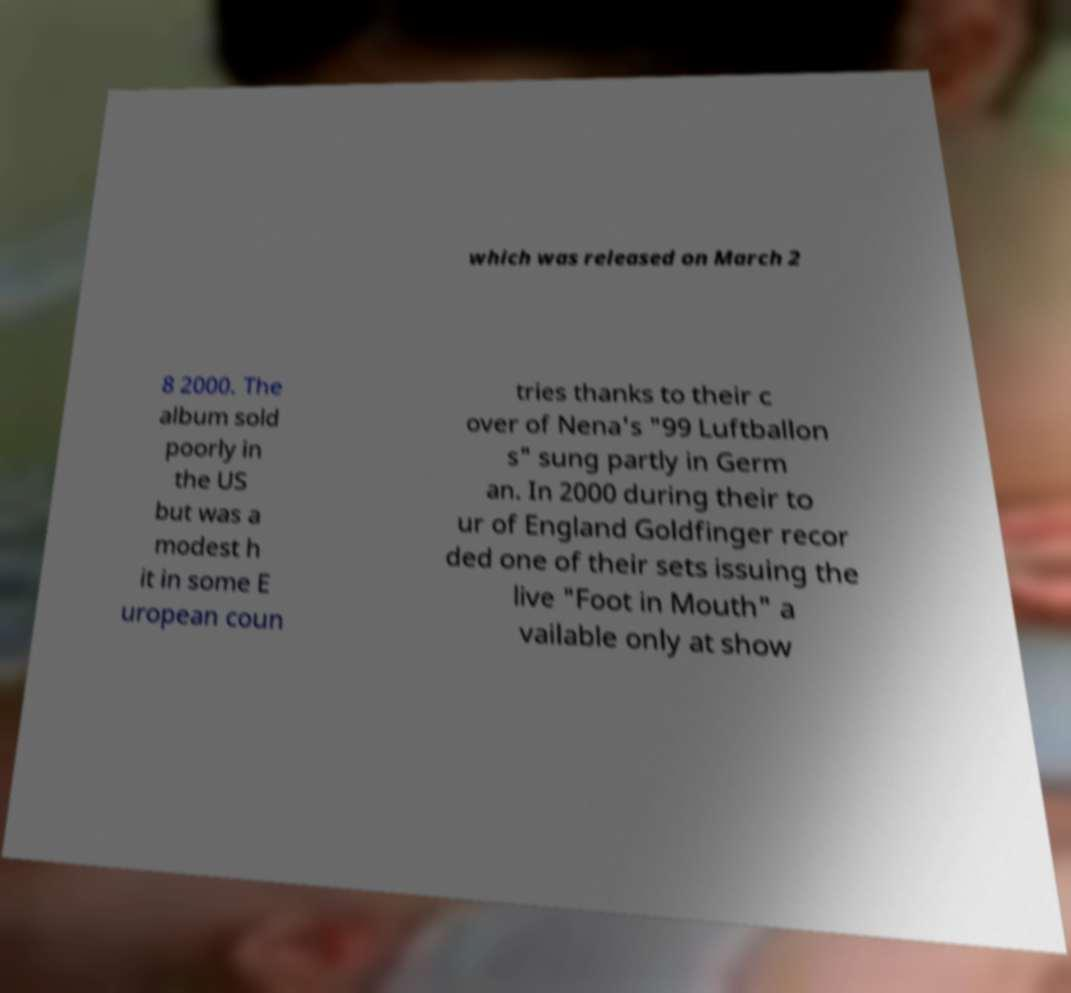Please read and relay the text visible in this image. What does it say? which was released on March 2 8 2000. The album sold poorly in the US but was a modest h it in some E uropean coun tries thanks to their c over of Nena's "99 Luftballon s" sung partly in Germ an. In 2000 during their to ur of England Goldfinger recor ded one of their sets issuing the live "Foot in Mouth" a vailable only at show 